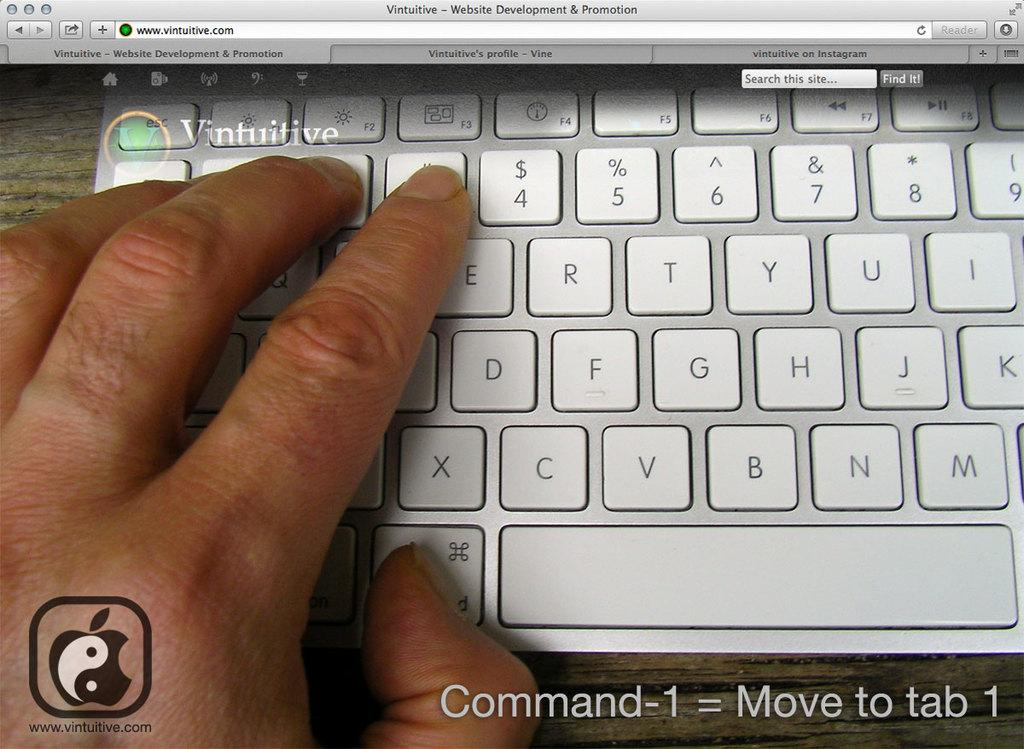<image>
Offer a succinct explanation of the picture presented. Command-1 = Move to tab 1 is the caption shown below this keyboard. 